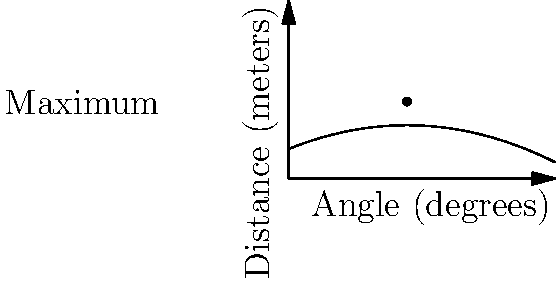In baseball, the distance a home run travels depends on the angle at which the ball is hit. The relationship between the angle and distance can be modeled by a polynomial equation. Using the graph provided, which shows the relationship between the angle of the hit and the distance the ball travels, what is the optimal angle for hitting a home run to achieve maximum distance? To find the optimal angle for hitting a home run, we need to analyze the given polynomial graph. Let's break it down step-by-step:

1. The graph represents the relationship between the angle of the hit (x-axis) and the distance the ball travels (y-axis).

2. The shape of the graph is parabolic, which is characteristic of a quadratic function (a second-degree polynomial).

3. In a parabola that opens downward (as in this case), the vertex represents the maximum point.

4. The vertex of this parabola is clearly marked on the graph with a dot and labeled "Maximum".

5. To find the x-coordinate of this maximum point, we need to identify where the vertex is located on the x-axis.

6. By examining the graph, we can see that the vertex is located at approximately 40 degrees on the x-axis.

Therefore, the optimal angle for hitting a home run to achieve maximum distance is about 40 degrees.

This result aligns with physics principles, where the optimal launch angle for projectile motion in a vacuum is 45 degrees. In reality, due to air resistance and other factors, the optimal angle for hitting a baseball is slightly lower, typically around 35-45 degrees.
Answer: 40 degrees 